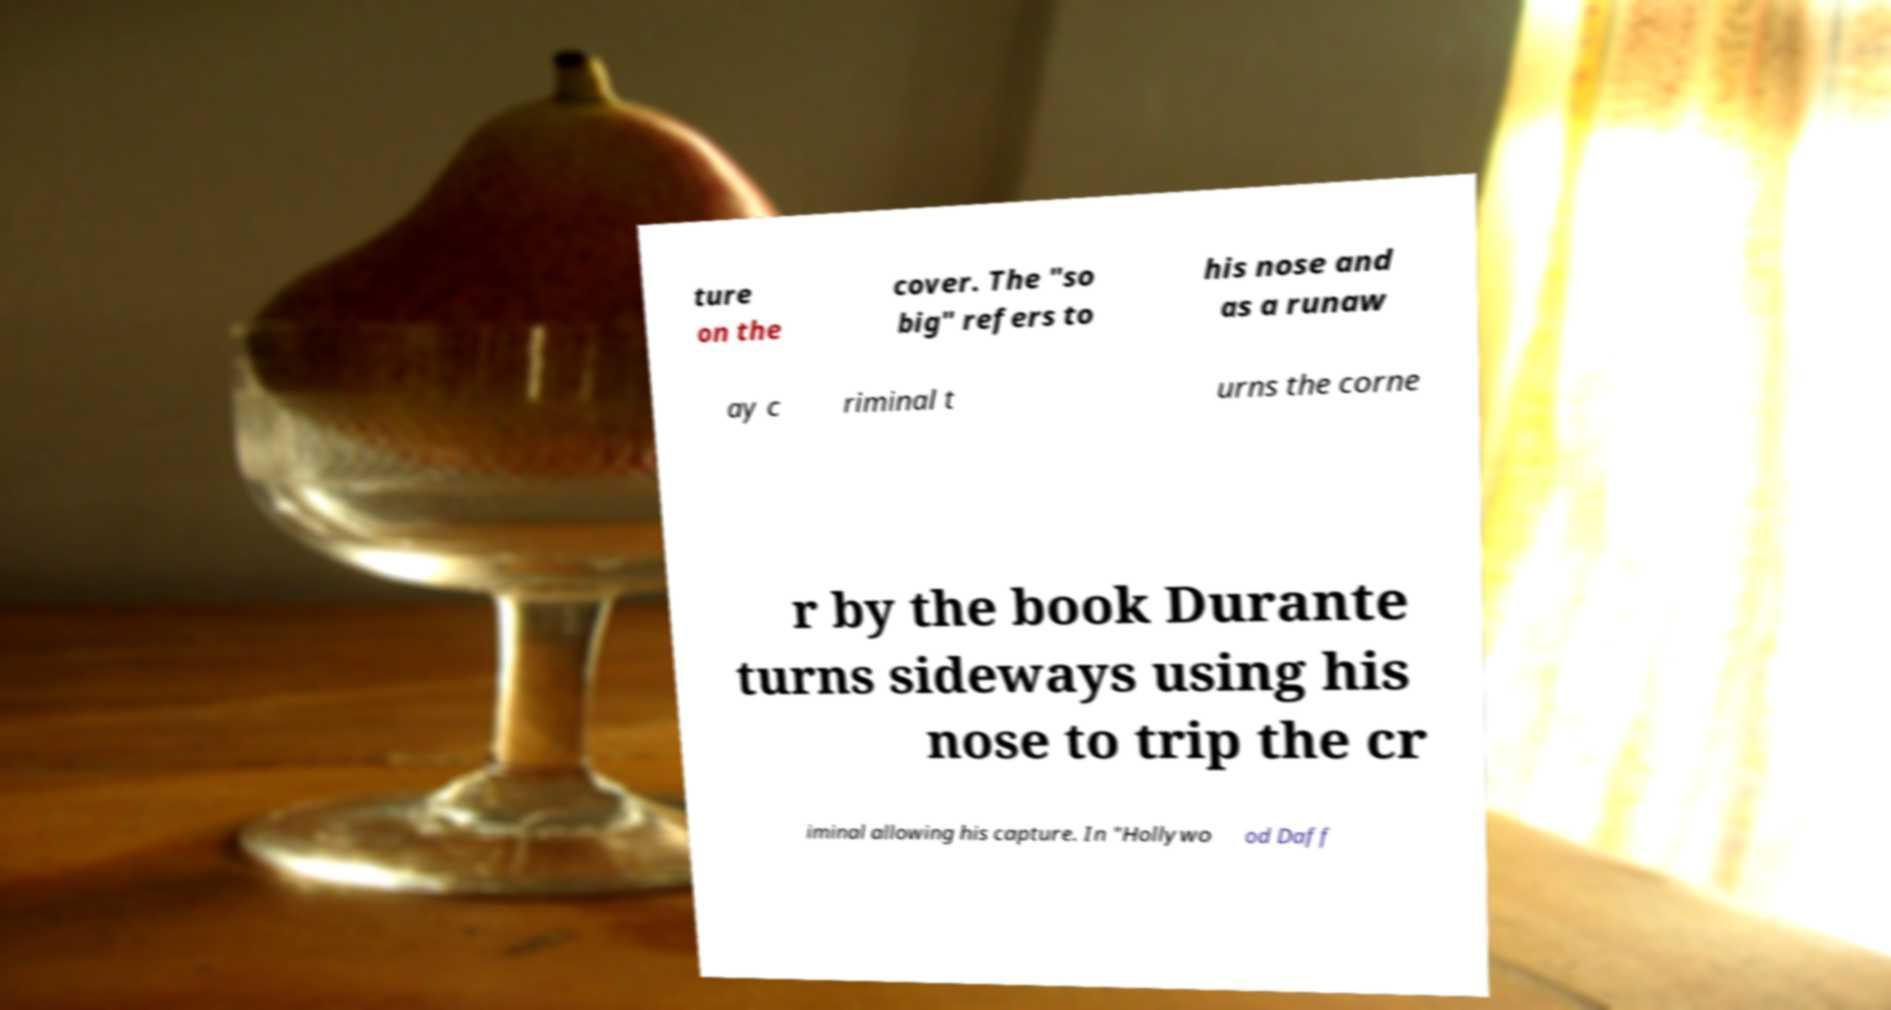Can you read and provide the text displayed in the image?This photo seems to have some interesting text. Can you extract and type it out for me? ture on the cover. The "so big" refers to his nose and as a runaw ay c riminal t urns the corne r by the book Durante turns sideways using his nose to trip the cr iminal allowing his capture. In "Hollywo od Daff 